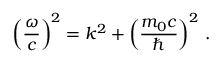<formula> <loc_0><loc_0><loc_500><loc_500>\left ( { \frac { \omega } { c } } \right ) ^ { 2 } = k ^ { 2 } + \left ( { \frac { m _ { 0 } c } { } } \right ) ^ { 2 } \, .</formula> 